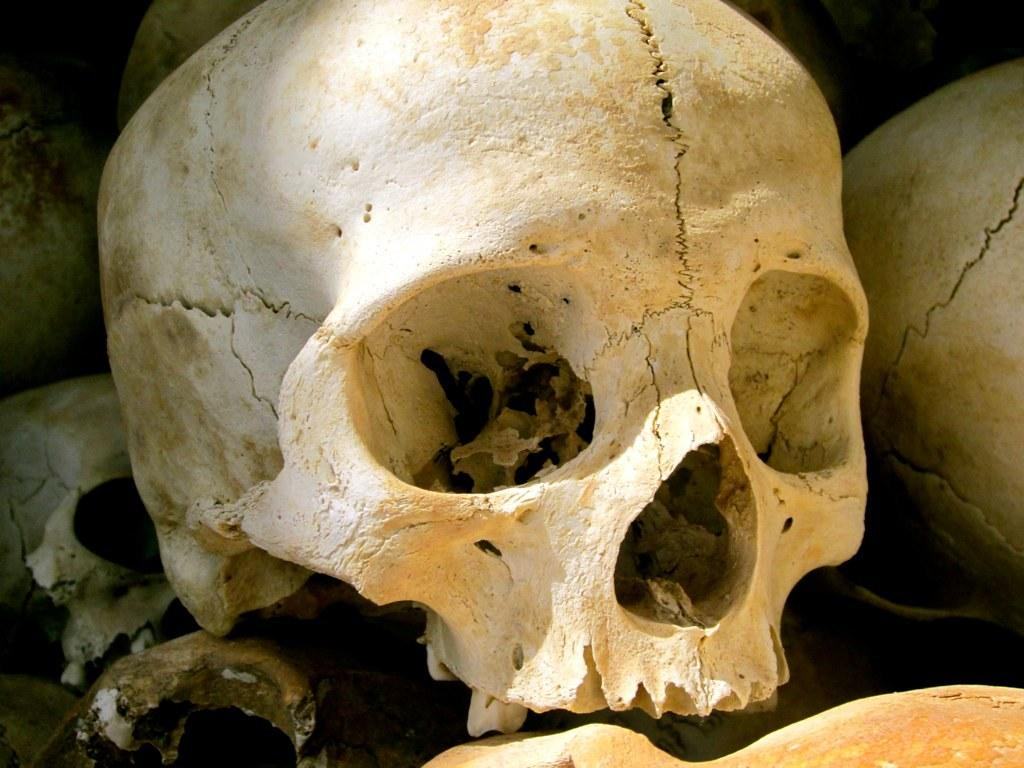What type of objects are present in the image? There are skulls in the image. What is the condition of the skulls? The skulls have cracks. What color are the skulls? The skulls are white in color. How many frogs can be seen kissing in the image? There are no frogs or kissing depicted in the image; it features skulls with cracks. 